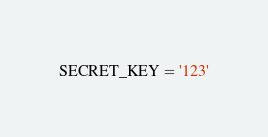<code> <loc_0><loc_0><loc_500><loc_500><_Python_>SECRET_KEY = '123'</code> 